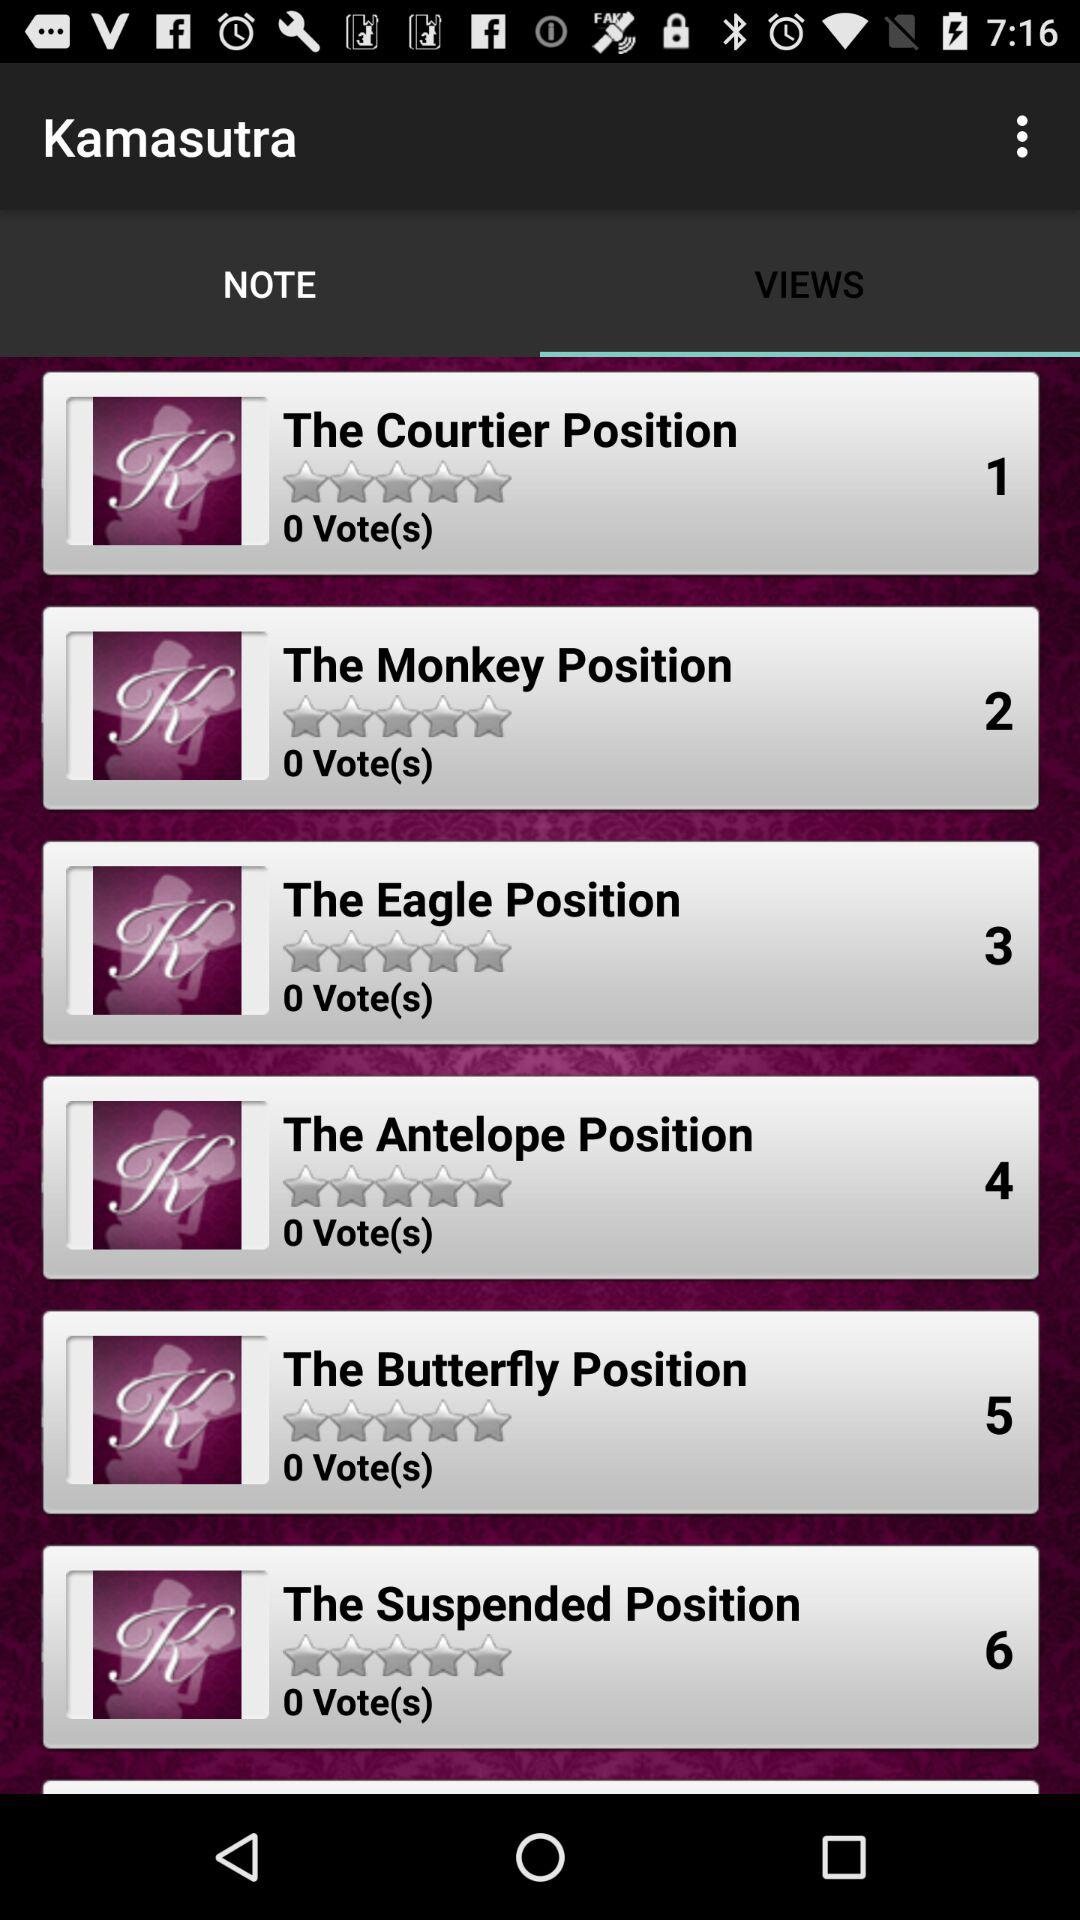How many votes are given to "The Monkey Position"? There are 0 votes given. 